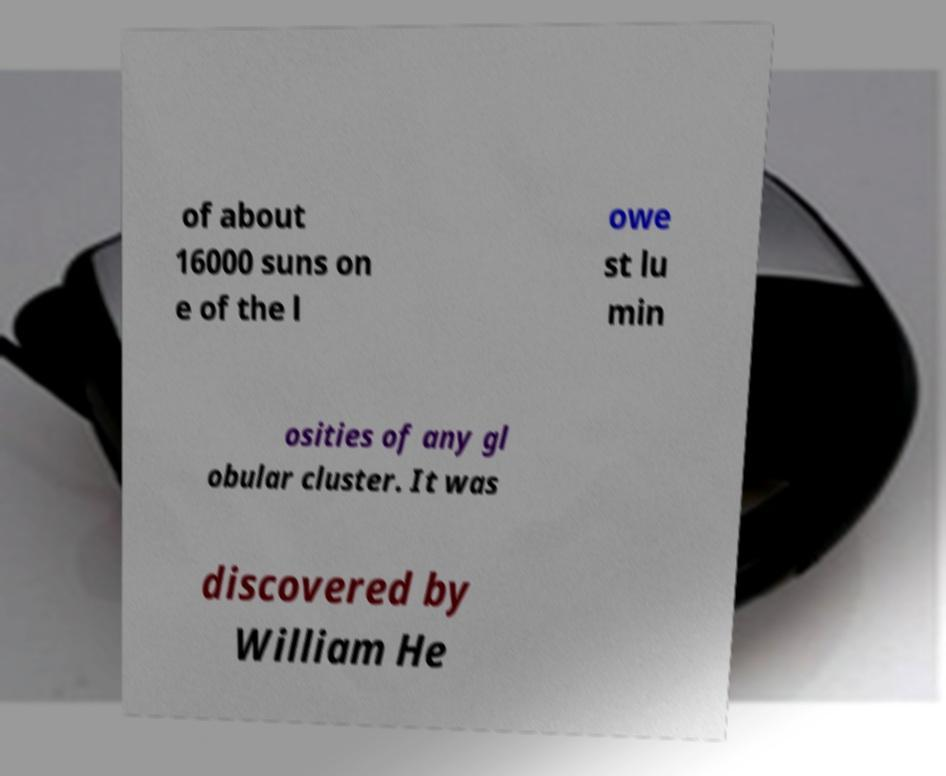There's text embedded in this image that I need extracted. Can you transcribe it verbatim? of about 16000 suns on e of the l owe st lu min osities of any gl obular cluster. It was discovered by William He 